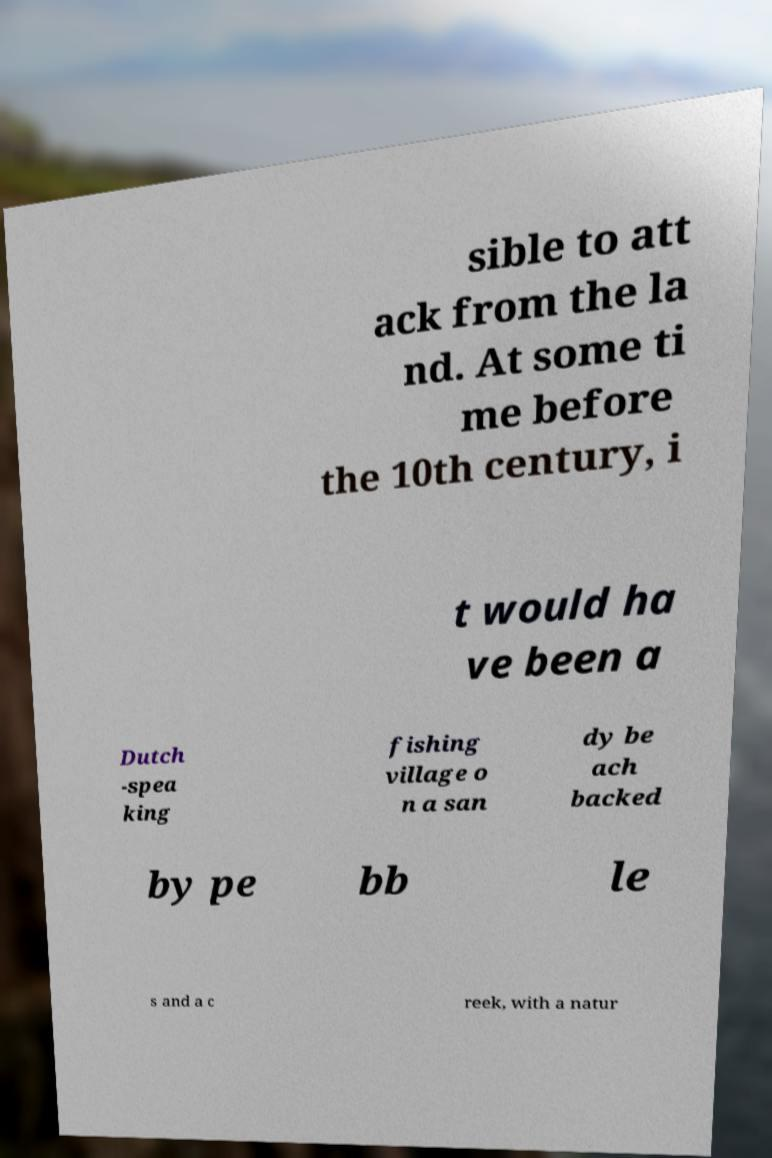Please identify and transcribe the text found in this image. sible to att ack from the la nd. At some ti me before the 10th century, i t would ha ve been a Dutch -spea king fishing village o n a san dy be ach backed by pe bb le s and a c reek, with a natur 